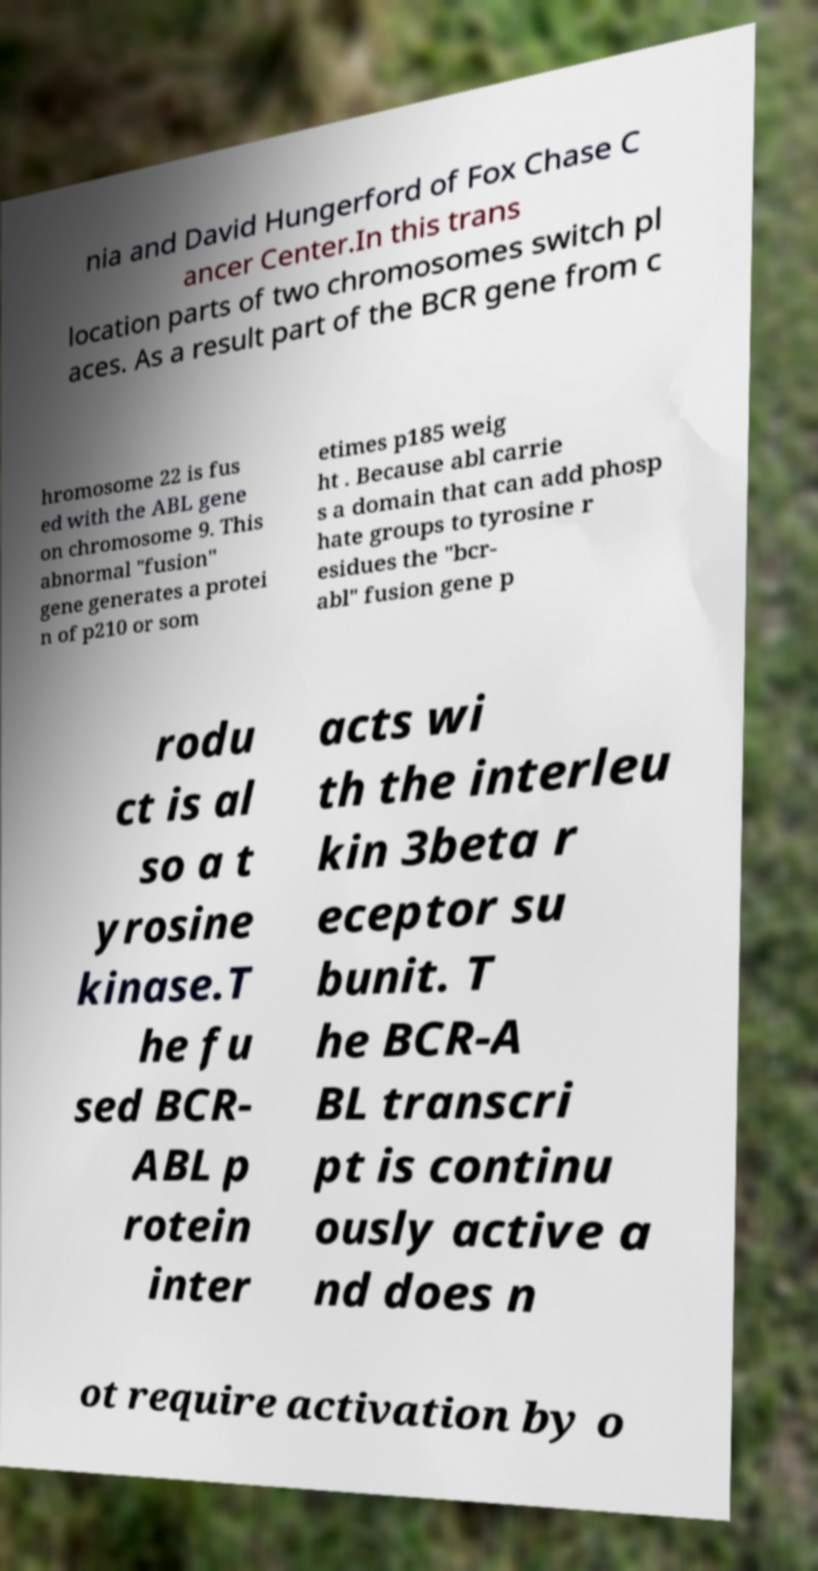Could you extract and type out the text from this image? nia and David Hungerford of Fox Chase C ancer Center.In this trans location parts of two chromosomes switch pl aces. As a result part of the BCR gene from c hromosome 22 is fus ed with the ABL gene on chromosome 9. This abnormal "fusion" gene generates a protei n of p210 or som etimes p185 weig ht . Because abl carrie s a domain that can add phosp hate groups to tyrosine r esidues the "bcr- abl" fusion gene p rodu ct is al so a t yrosine kinase.T he fu sed BCR- ABL p rotein inter acts wi th the interleu kin 3beta r eceptor su bunit. T he BCR-A BL transcri pt is continu ously active a nd does n ot require activation by o 